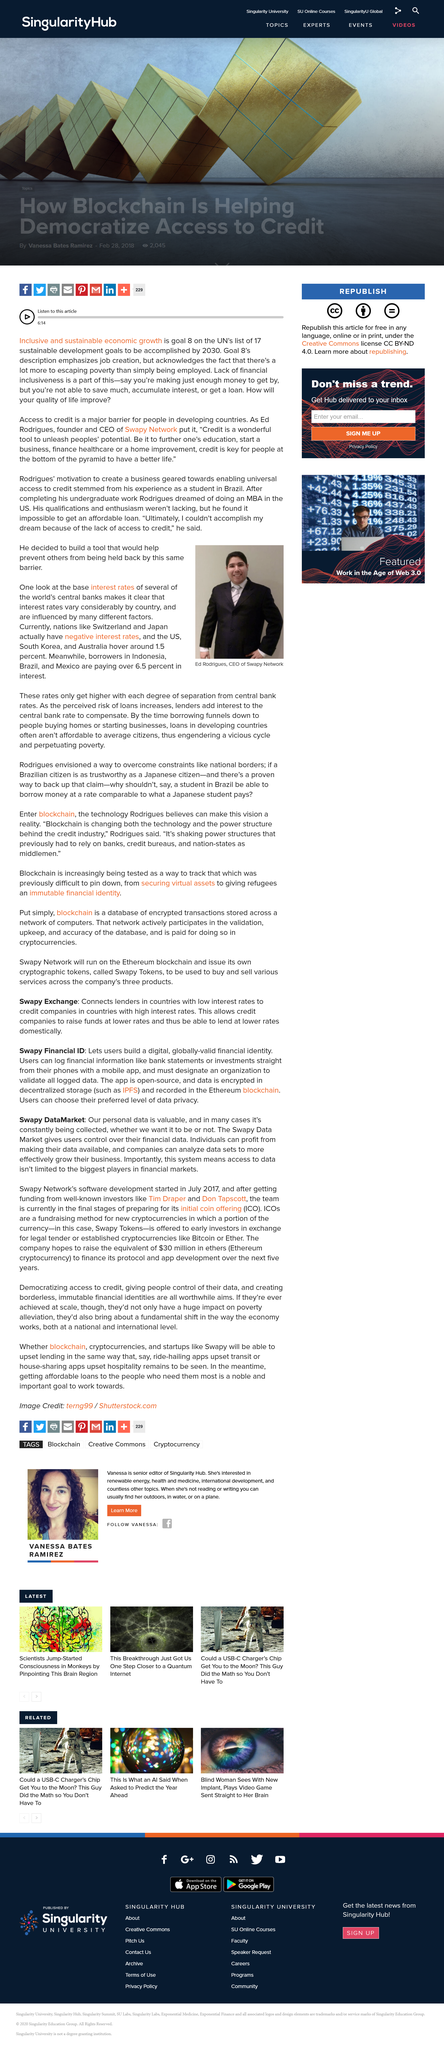Highlight a few significant elements in this photo. It is known that the CEO of Swapy Network is named Ed Rodrigues. Switzerland and Japan are the nations that currently have negative interest rates. Borrowers in Indonesia, Brazil, and Mexico typically pay 6.5% in interest on their loans. 